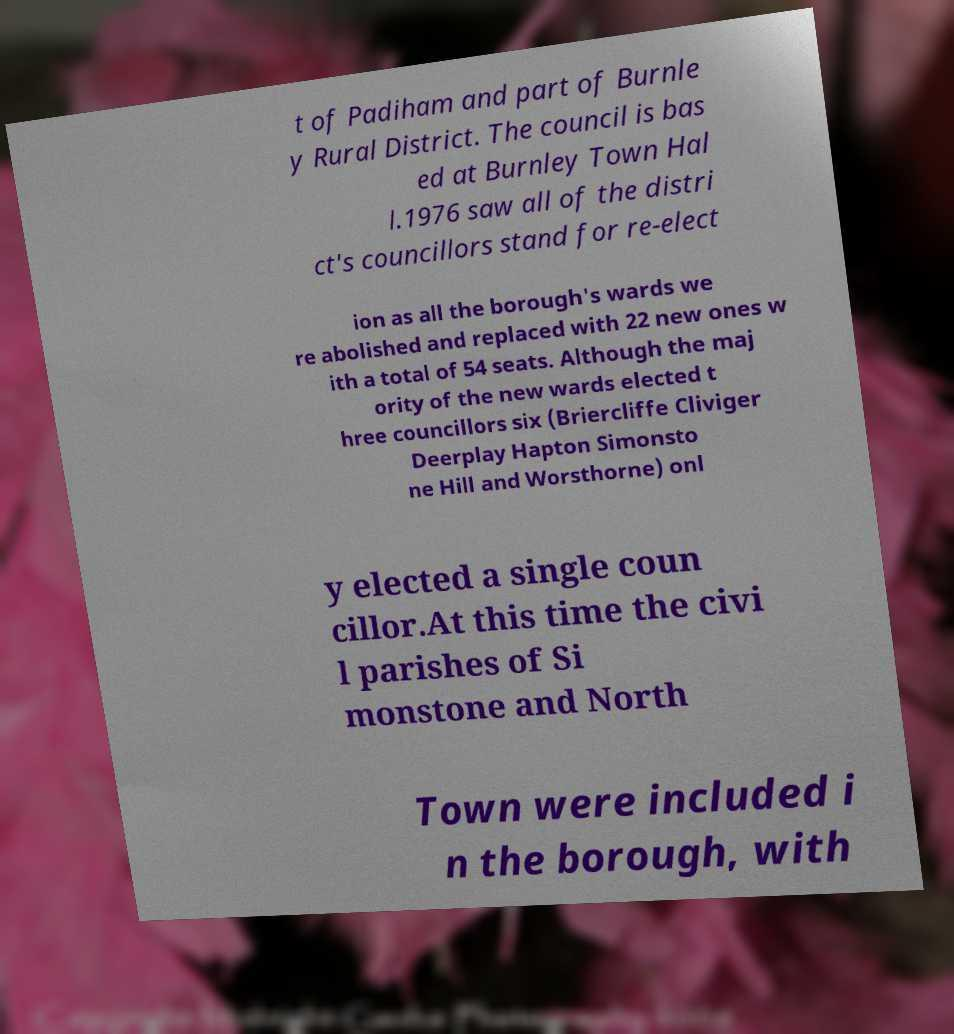Can you accurately transcribe the text from the provided image for me? t of Padiham and part of Burnle y Rural District. The council is bas ed at Burnley Town Hal l.1976 saw all of the distri ct's councillors stand for re-elect ion as all the borough's wards we re abolished and replaced with 22 new ones w ith a total of 54 seats. Although the maj ority of the new wards elected t hree councillors six (Briercliffe Cliviger Deerplay Hapton Simonsto ne Hill and Worsthorne) onl y elected a single coun cillor.At this time the civi l parishes of Si monstone and North Town were included i n the borough, with 